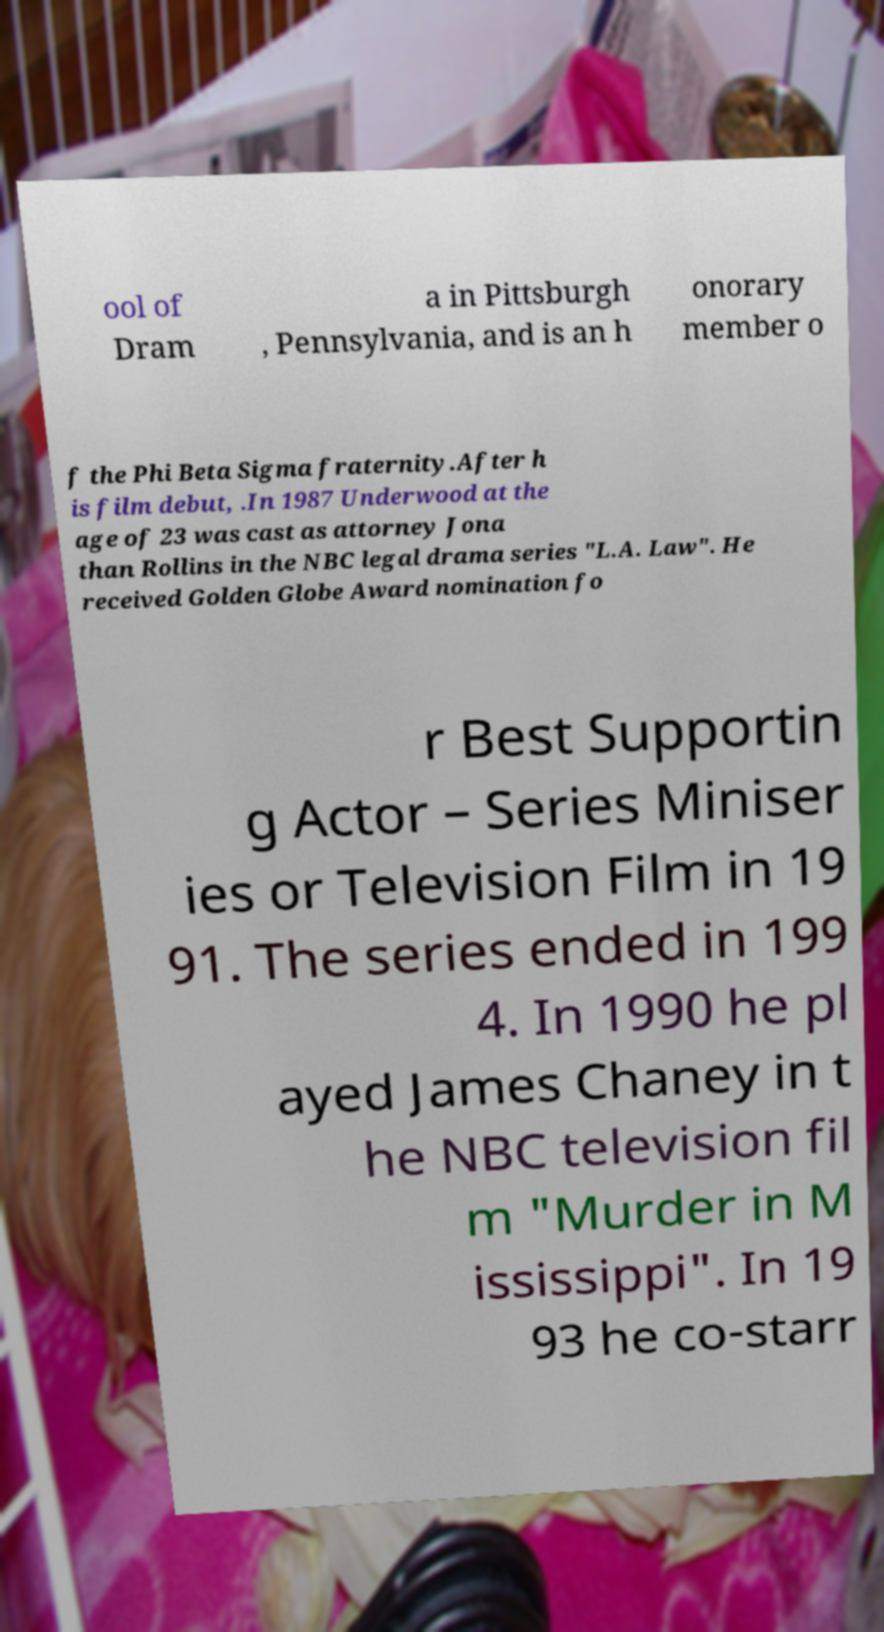Please read and relay the text visible in this image. What does it say? ool of Dram a in Pittsburgh , Pennsylvania, and is an h onorary member o f the Phi Beta Sigma fraternity.After h is film debut, .In 1987 Underwood at the age of 23 was cast as attorney Jona than Rollins in the NBC legal drama series "L.A. Law". He received Golden Globe Award nomination fo r Best Supportin g Actor – Series Miniser ies or Television Film in 19 91. The series ended in 199 4. In 1990 he pl ayed James Chaney in t he NBC television fil m "Murder in M ississippi". In 19 93 he co-starr 